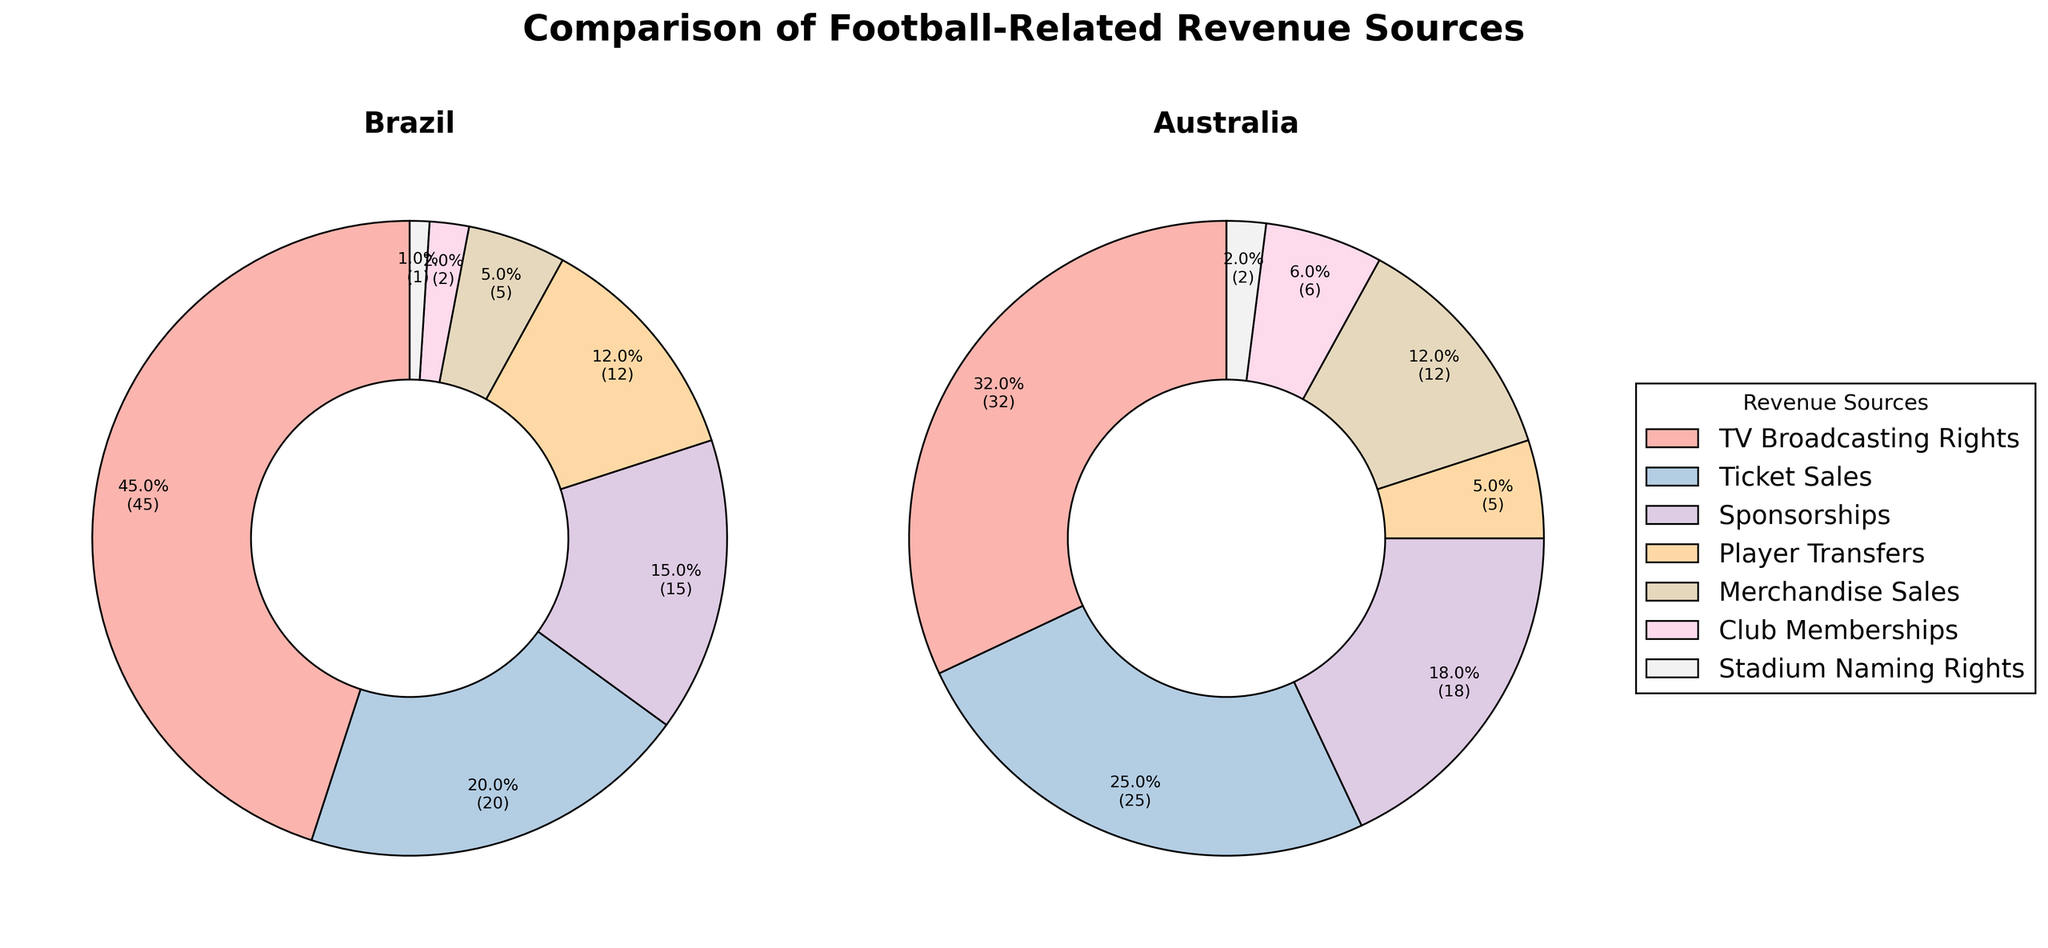Which country has a higher percentage of revenue from TV Broadcasting Rights? Brazil has a higher percentage. From the pie chart, Brazil generates 45% of its football-related revenue from TV Broadcasting Rights, whereas Australia generates 32% from the same source.
Answer: Brazil What is the combined percentage of revenue from Player Transfers and Merchandise Sales in Australia? In Australia, Player Transfers account for 5%, and Merchandise Sales account for 12%. Adding these percentages: 5% + 12% = 17%.
Answer: 17% Which country's football-related revenue relies more heavily on Sponsorships? Brazil’s revenue from Sponsorships is indicated at 15%, while for Australia it is 18%. Thus, Australia relies more heavily on Sponsorships.
Answer: Australia For Brazil, how much greater is the revenue share from Ticket Sales compared to Club Memberships? Brazil’s Ticket Sales revenue share is 20%, while Club Memberships contribute 2%. Subtracting the two percentages: 20% - 2% = 18%.
Answer: 18% Which revenue source has the smallest percentage in Australia and what is it? In Australia, the smallest revenue source is Stadium Naming Rights, at 2%.
Answer: Stadium Naming Rights Compare the combined revenue percentages from Ticket Sales and Club Memberships for both countries. Which country has a higher total percentage from these revenue sources? For Brazil: Ticket Sales (20%) + Club Memberships (2%) = 22%. For Australia: Ticket Sales (25%) + Club Memberships (6%) = 31%. Australia has a higher combined percentage from these revenue sources.
Answer: Australia Between Brazil and Australia, which country has a higher reliance on Merchandise Sales and by how much? Brazil's Merchandise Sales contribute 5%, while Australia's are 12%. Subtracting these gives: 12% - 5% = 7%. Australia has a 7% higher reliance on Merchandise Sales.
Answer: Australia, by 7% What percentage of revenue in Brazil comes from non-broadcasting sources? Brazil’s non-broadcasting revenue is the sum of all sources except TV Broadcasting Rights: 20% (Ticket Sales) + 15% (Sponsorships) + 12% (Player Transfers) + 5% (Merchandise Sales) + 2% (Club Memberships) + 1% (Stadium Naming Rights) = 55%.
Answer: 55% By how much does Australia's percentage from Ticket Sales exceed that of Brazil? Australia’s Ticket Sales is 25%, and Brazil’s is 20%. The difference is 25% - 20% = 5%.
Answer: 5% 